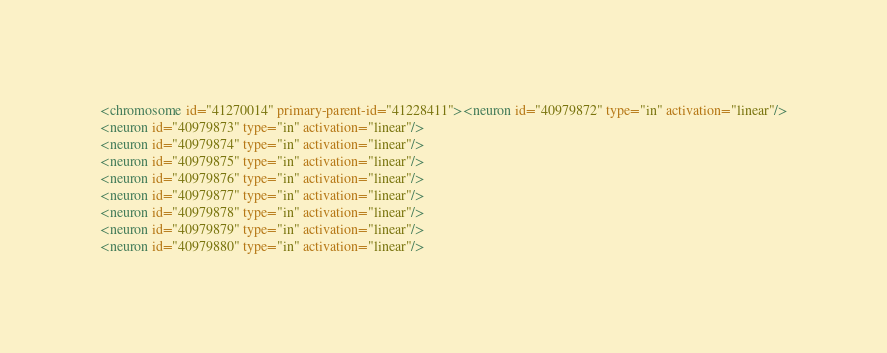<code> <loc_0><loc_0><loc_500><loc_500><_XML_><chromosome id="41270014" primary-parent-id="41228411"><neuron id="40979872" type="in" activation="linear"/>
<neuron id="40979873" type="in" activation="linear"/>
<neuron id="40979874" type="in" activation="linear"/>
<neuron id="40979875" type="in" activation="linear"/>
<neuron id="40979876" type="in" activation="linear"/>
<neuron id="40979877" type="in" activation="linear"/>
<neuron id="40979878" type="in" activation="linear"/>
<neuron id="40979879" type="in" activation="linear"/>
<neuron id="40979880" type="in" activation="linear"/></code> 